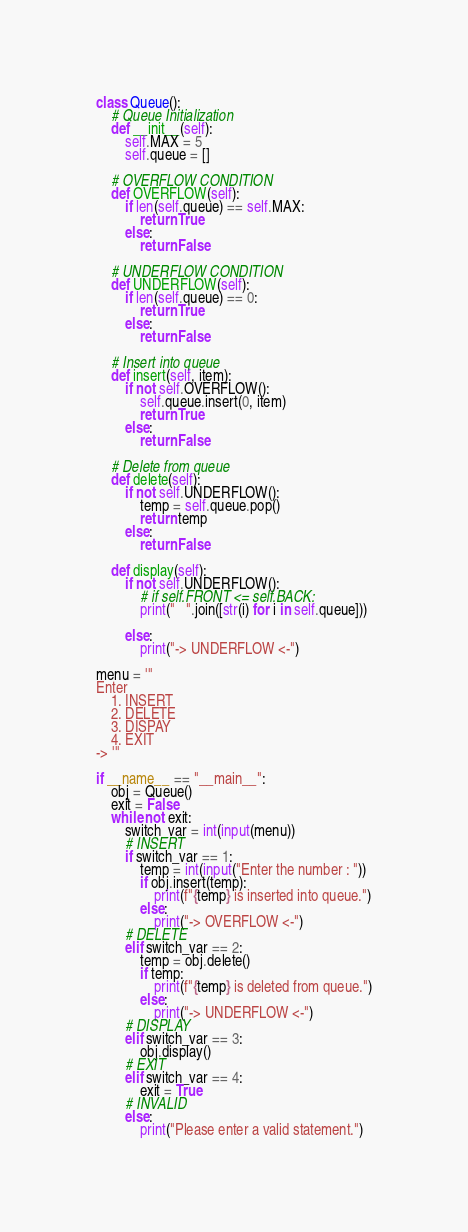<code> <loc_0><loc_0><loc_500><loc_500><_Python_>class Queue():
	# Queue Initialization
	def __init__(self):
		self.MAX = 5
		self.queue = []

	# OVERFLOW CONDITION
	def OVERFLOW(self):
		if len(self.queue) == self.MAX:
			return True
		else:
			return False

	# UNDERFLOW CONDITION
	def UNDERFLOW(self):
		if len(self.queue) == 0:
			return True
		else:
			return False
	
	# Insert into queue
	def insert(self, item):
		if not self.OVERFLOW():
			self.queue.insert(0, item)
			return True
		else:
			return False
	
	# Delete from queue
	def delete(self):
		if not self.UNDERFLOW():
			temp = self.queue.pop()
			return temp
		else:
			return False
	
	def display(self):
		if not self.UNDERFLOW():
			# if self.FRONT <= self.BACK:
			print("   ".join([str(i) for i in self.queue]))

		else:
			print("-> UNDERFLOW <-")

menu = '''
Enter
	1. INSERT
	2. DELETE
	3. DISPAY
	4. EXIT
-> '''

if __name__ == "__main__":
	obj = Queue()
	exit = False
	while not exit:
		switch_var = int(input(menu))
		# INSERT
		if switch_var == 1:
			temp = int(input("Enter the number : "))
			if obj.insert(temp):
				print(f"{temp} is inserted into queue.")
			else:
				print("-> OVERFLOW <-")
		# DELETE
		elif switch_var == 2:
			temp = obj.delete()
			if temp:
				print(f"{temp} is deleted from queue.")
			else:
				print("-> UNDERFLOW <-")
		# DISPLAY
		elif switch_var == 3:
			obj.display()
		# EXIT
		elif switch_var == 4:
			exit = True
		# INVALID
		else:
			print("Please enter a valid statement.")
</code> 